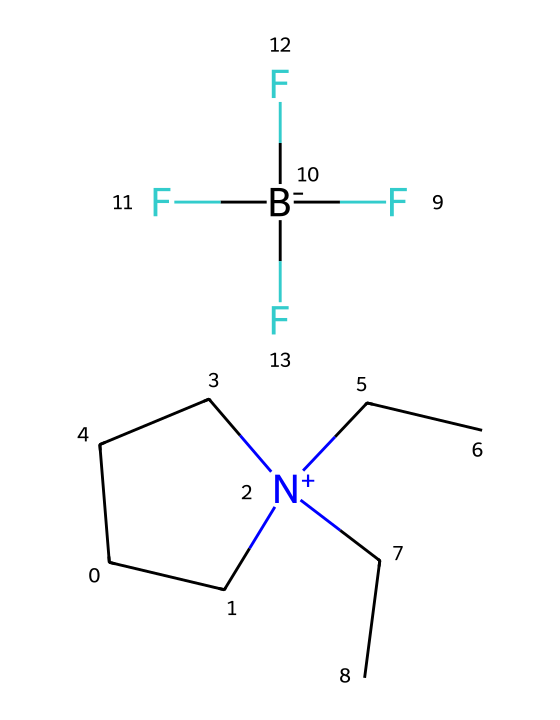What is the main cation in this ionic liquid? The cation can be identified from the SMILES notation; it indicates a cyclic structure with a nitrogen atom carrying a positive charge. The presence of a quaternary ammonium ion suggests the cation is derived from N-alkylpyrrolidinium.
Answer: N-alkylpyrrolidinium How many fluorine atoms are present in this ionic liquid? The SMILES contains a section that indicates a trifluoromethyl group, represented as F[B-](F)(F)F, signifying there are three fluorine atoms bonded to the boron.
Answer: three What type of anion is represented in this ionic liquid? The molecular notation shows the presence of boron and multiple fluorine atoms, indicating a tetrahedral geometry associated with a boron anion. This is characteristic of a perfluoroborate ion.
Answer: perfluoroborate What is the total number of carbon atoms in the structure? Counting from the SMILES string, each carbon is represented clearly as 'C' or part of the cyclic structure. There are a total of 8 carbon atoms corresponding to the cyclic and linear portion of the cation and anion structure.
Answer: eight What characteristic property does the positive charge on nitrogen contribute to this ionic liquid? The positive charge on nitrogen creates ionic interactions with the anion, resulting in low volatility and enhancing thermal stability. This is a characteristic trait of ionic liquids that makes them suitable for cooling applications.
Answer: low volatility What molecular feature allows this ionic liquid to function in cooling systems? The presence of both the organic cation and the inorganic anion allows for a wide liquid temperature range with excellent thermal and electrochemical stability, essential for effective cooling.
Answer: wide liquid temperature range 